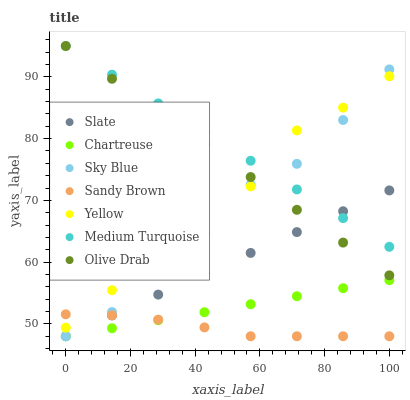Does Sandy Brown have the minimum area under the curve?
Answer yes or no. Yes. Does Medium Turquoise have the maximum area under the curve?
Answer yes or no. Yes. Does Yellow have the minimum area under the curve?
Answer yes or no. No. Does Yellow have the maximum area under the curve?
Answer yes or no. No. Is Slate the smoothest?
Answer yes or no. Yes. Is Sky Blue the roughest?
Answer yes or no. Yes. Is Yellow the smoothest?
Answer yes or no. No. Is Yellow the roughest?
Answer yes or no. No. Does Slate have the lowest value?
Answer yes or no. Yes. Does Yellow have the lowest value?
Answer yes or no. No. Does Olive Drab have the highest value?
Answer yes or no. Yes. Does Yellow have the highest value?
Answer yes or no. No. Is Slate less than Yellow?
Answer yes or no. Yes. Is Olive Drab greater than Sandy Brown?
Answer yes or no. Yes. Does Slate intersect Olive Drab?
Answer yes or no. Yes. Is Slate less than Olive Drab?
Answer yes or no. No. Is Slate greater than Olive Drab?
Answer yes or no. No. Does Slate intersect Yellow?
Answer yes or no. No. 